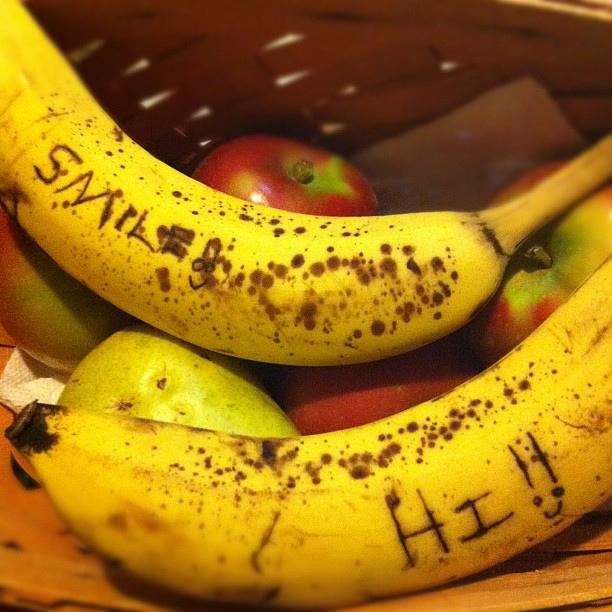What is on the fruit? words 